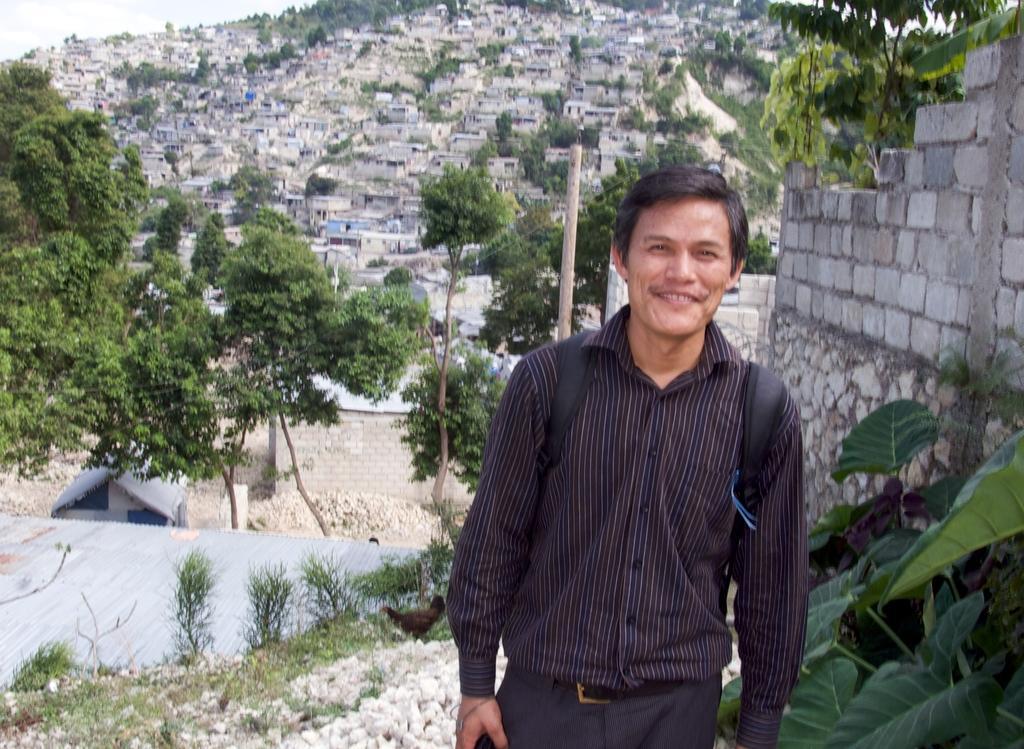How would you summarize this image in a sentence or two? In the picture I can see a man is standing on the ground and smiling. In the background I can see houses, buildings, a pole, trees, plants and a wall. On the left the image I can see the sky. 